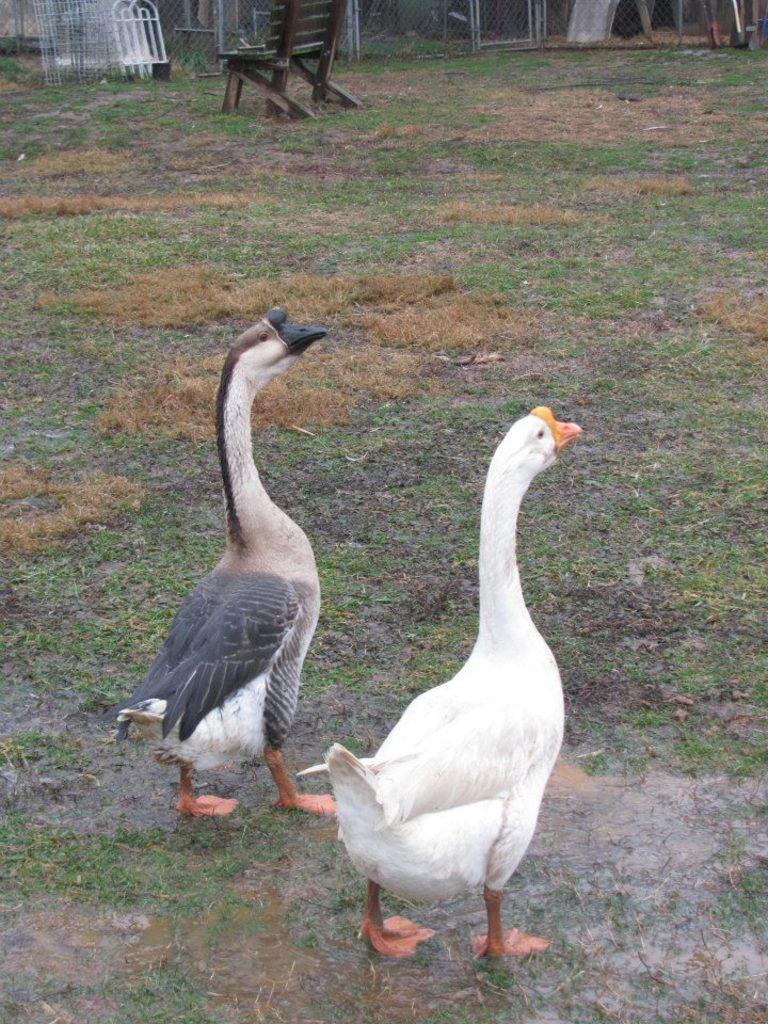What type of animals can be seen in the image? There are birds in the image. What type of vegetation is present in the image? There is grass in the image. What type of object can be seen in the image that might be used for sitting? There is a chair in the image. What can be seen in the background of the image? There is a fence in the background of the image. How many jellyfish are swimming in the grass in the image? There are no jellyfish present in the image; it features birds and grass. What type of battle is taking place in the background of the image? There is no battle present in the image; it features a fence in the background. 